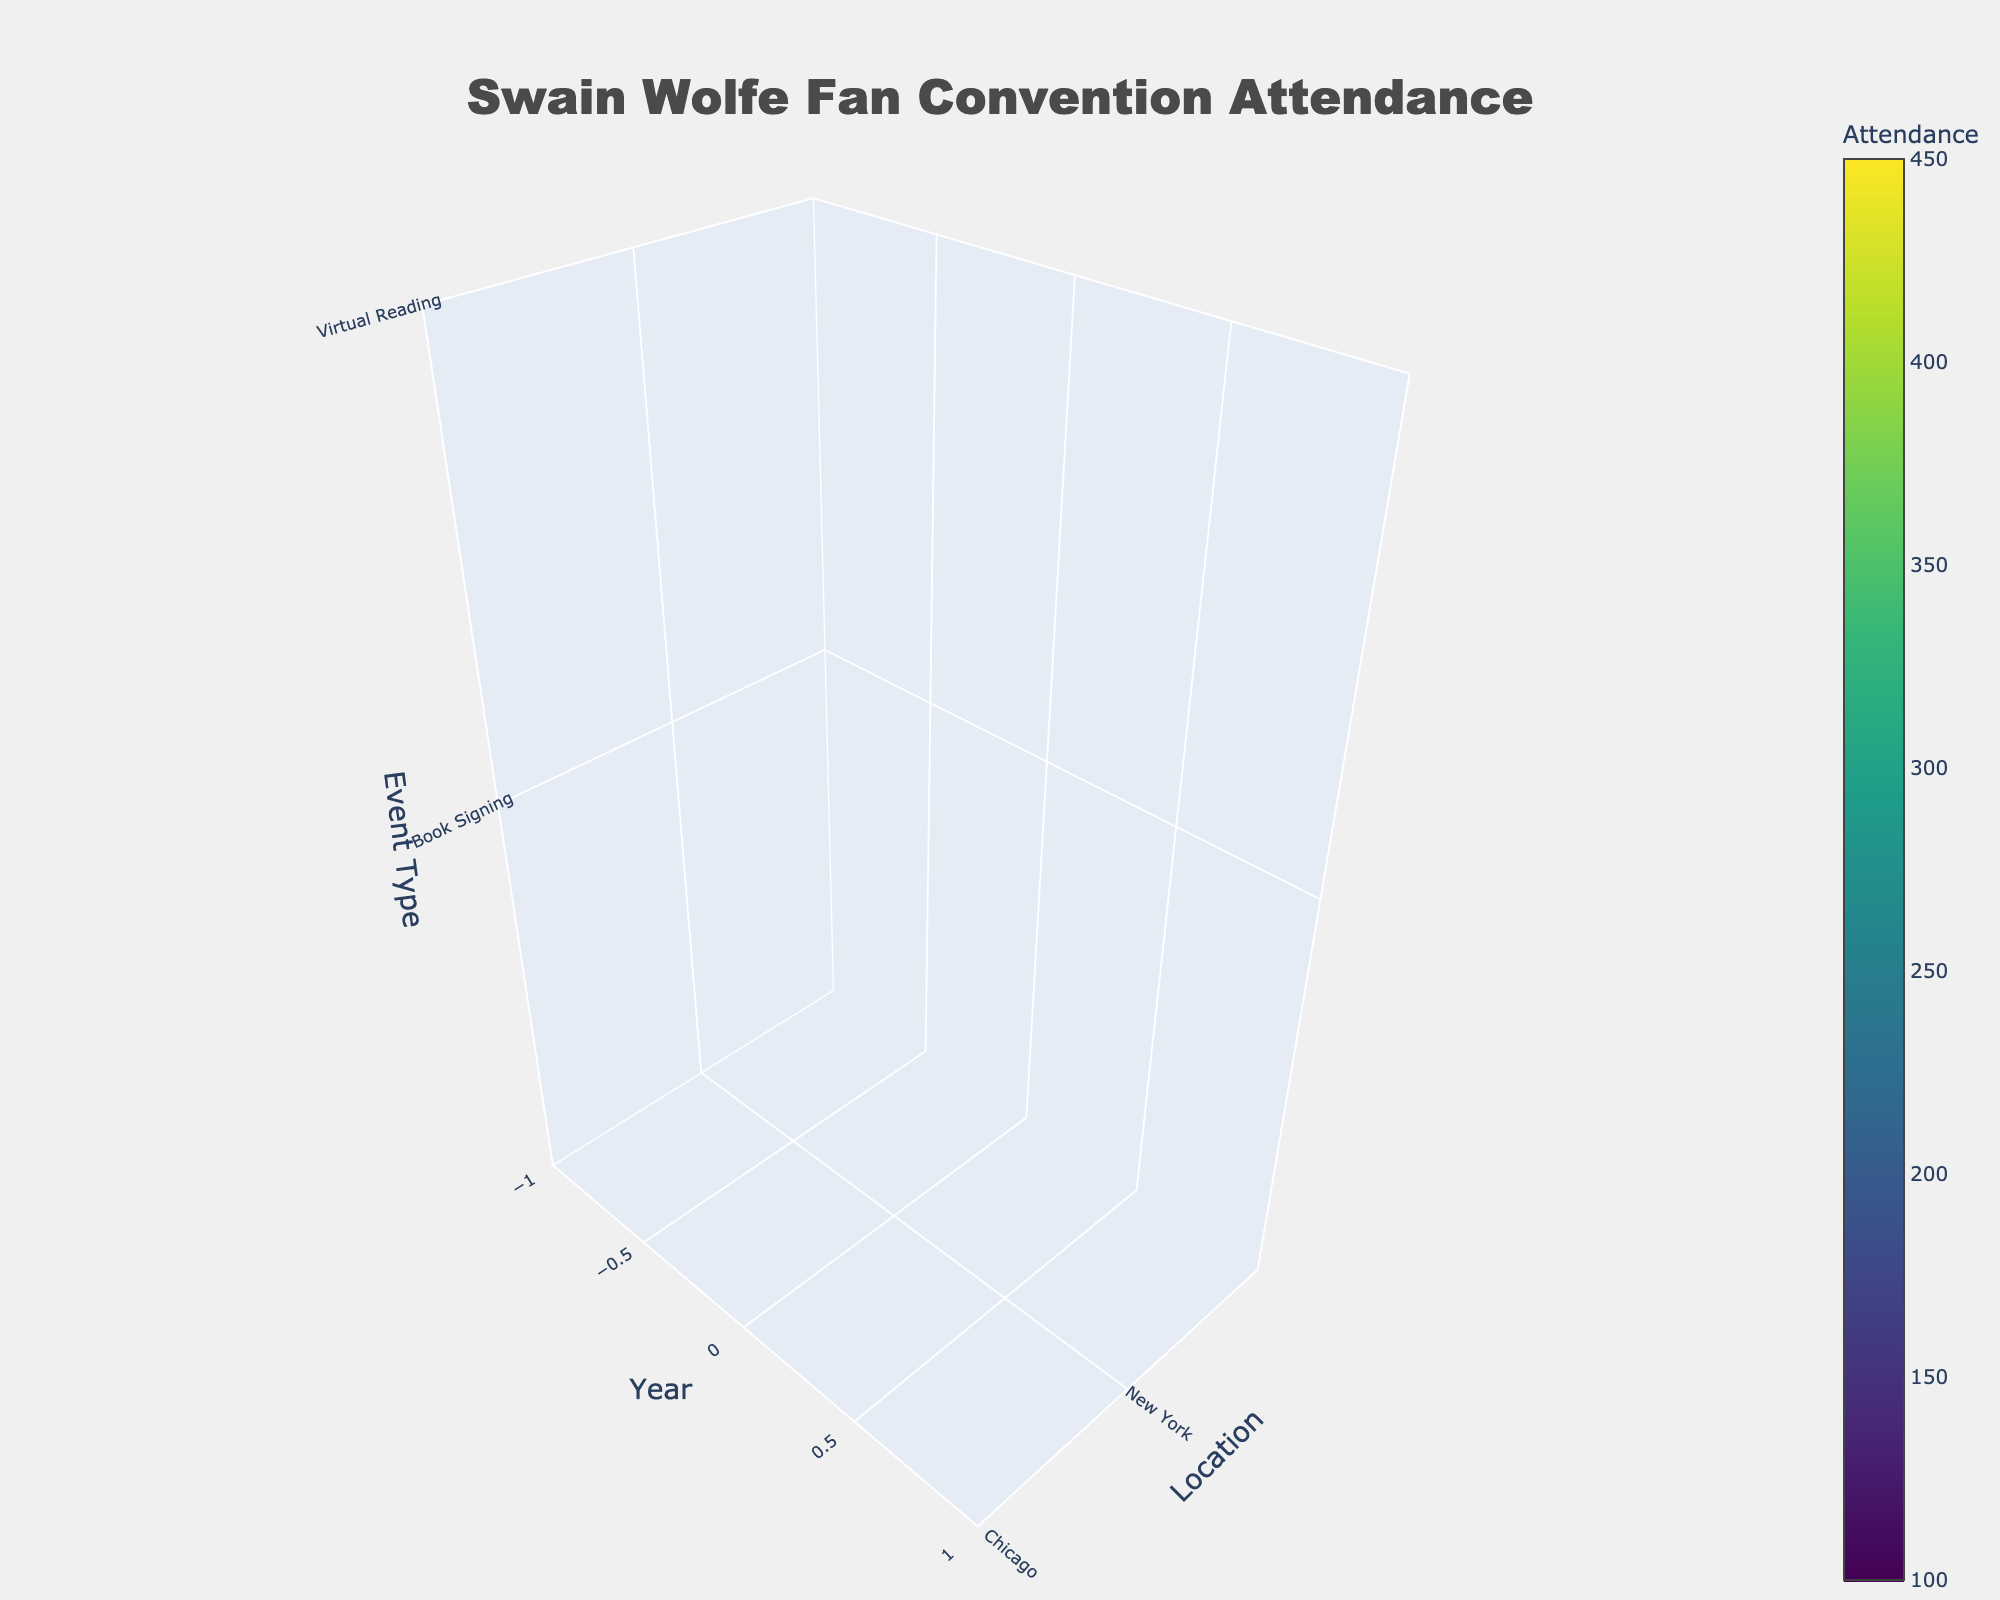what is the title of the plot? The title is typically located at the top of the plot. For this plot, it clearly states what the plot is about.
Answer: Swain Wolfe Fan Convention Attendance Which location had the highest attendance in 2021? By examining the z-axis (event types), y-axis (years), and the colors for each location, we can compare the attendance values for 2021. Seattle's section shows the highest attendance for Virtual Fan Meet.
Answer: Seattle How does attendance change from 2018 to 2021 for New York? We need to compare the values for each year within New York. Attendance grows from 150 in 2018 to 350 in 2021.
Answer: It increases Which event type had the highest attendance in San Francisco in 2021? Look at the z-axis for event types and check the specific section for San Francisco in 2021. The Virtual Workshop event shows the maximal attendance here.
Answer: Virtual Workshop Which year had the lowest overall attendance? Consider the range of values across all locations and event types for each year. 2018 has consistently lower attendance figures across the board.
Answer: 2018 What is the average attendance of Virtual events in 2020 across all locations? Identify the locations where Virtual events were held in 2020 and average their attendance figures: New York (300), Chicago (280), San Francisco (250), Boston (270), Seattle (400). [(300 + 280 + 250 + 270 + 400)/5] = 300.
Answer: 300 How did the attendance at the Fan Convention in Seattle change from 2018 to 2021? Compare the data points in the Seattle section for the Fan Convention events over these years. Attendance increased from 300 to 450.
Answer: Increased Which location had greater attendance in 2019, Chicago or Boston? Compare the 2019 attendance values for Chicago and Boston. Chicago's Literary Festival attendance was 230 while Boston's Film Adaptation Premiere was 210.
Answer: Chicago Is the attendance generally higher for in-person events or virtual events? By examining both clusters of in-person (2018-2019) and virtual events (2020-2021) across locations, virtual events show consistently higher attendance.
Answer: Virtual events 